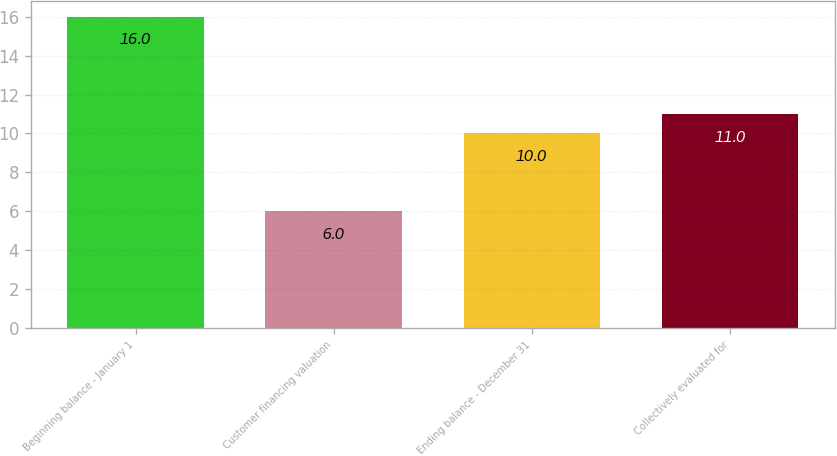<chart> <loc_0><loc_0><loc_500><loc_500><bar_chart><fcel>Beginning balance - January 1<fcel>Customer financing valuation<fcel>Ending balance - December 31<fcel>Collectively evaluated for<nl><fcel>16<fcel>6<fcel>10<fcel>11<nl></chart> 